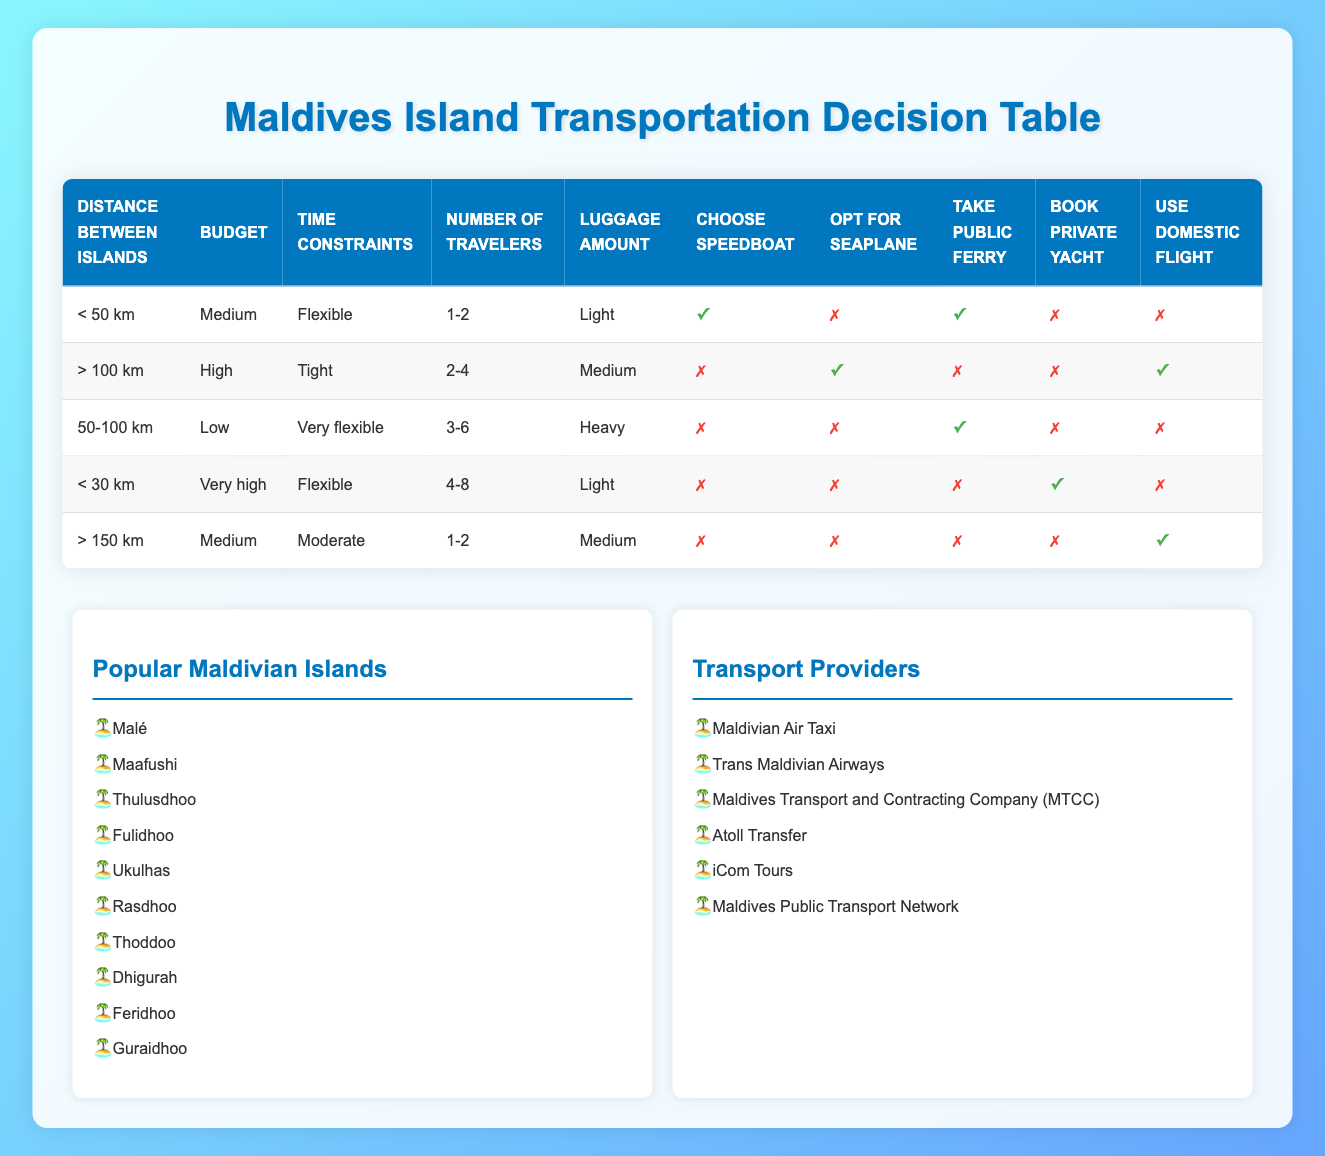What transportation options are available for travel between islands less than 50 km apart with a medium budget? In the table, we can find the row for "Distance between islands" as "< 50 km" and "Budget" as "Medium". The actions that are marked true in this row are "Choose speedboat" and "Take public ferry". Therefore, these are the available transportation options.
Answer: Choose speedboat, Take public ferry Is it possible to use a seaplane if the distance between the islands is greater than 100 km and the budget is low? Looking at the relevant row for "Distance between islands" as "> 100 km" and "Budget" as "Low", the action "Opt for seaplane" is marked false. This indicates that it is not possible to use a seaplane under these conditions.
Answer: No Which transportation option should be chosen if the distance is between 50-100 km, the budget is low, and the number of travelers is between 3-6 with heavy luggage? In the specified row for "Distance between islands" as "50-100 km", "Budget" as "Low", and "Number of travelers" as "3-6", the only action that is true is "Take public ferry". Thus, this is the recommended transportation option.
Answer: Take public ferry What are the best options for transportation if you have two travelers, a medium amount of luggage, and need to travel between islands further than 150 km with a medium budget? We find the row for "Distance between islands" as "> 150 km", "Budget" as "Medium", and "Number of travelers" as "1-2". In this case, the action "Use domestic flight" is true while all other options are false. Therefore, using a domestic flight is the best option.
Answer: Use domestic flight If traveling with 4-8 people and light luggage between islands that are less than 30 km apart, is booking a private yacht a good option? Referring to the row for "Distance between islands" as "< 30 km" and "Number of travelers" as "4-8", we see that "Book private yacht" is marked true. This means it is a viable option for this scenario.
Answer: Yes Which transportation methods are not suitable for a trip longer than 100 km with a high budget and tight time constraints for 2-4 travelers with a medium luggage amount? In the row for "Distance between islands" as "> 100 km", "Budget" as "High", "Time constraints" as "Tight", and "Number of travelers" as "2-4", "Choose speedboat", "Take public ferry", and "Book private yacht" are all false. Therefore, these methods are not suitable.
Answer: Choose speedboat, Take public ferry, Book private yacht Can a public ferry be used for traveling over 100 km with a low budget if traveling with 3-6 people? Checking the row indicating "Distance between islands" as "> 100 km", "Budget" as "Low", and "Number of travelers" as "3-6", the option "Take public ferry" is false. Thus, it cannot be used in this scenario.
Answer: No 